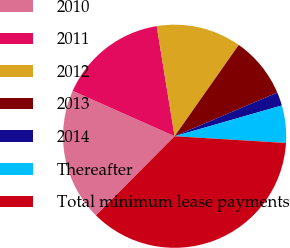<chart> <loc_0><loc_0><loc_500><loc_500><pie_chart><fcel>2010<fcel>2011<fcel>2012<fcel>2013<fcel>2014<fcel>Thereafter<fcel>Total minimum lease payments<nl><fcel>19.22%<fcel>15.77%<fcel>12.31%<fcel>8.86%<fcel>1.95%<fcel>5.41%<fcel>36.49%<nl></chart> 